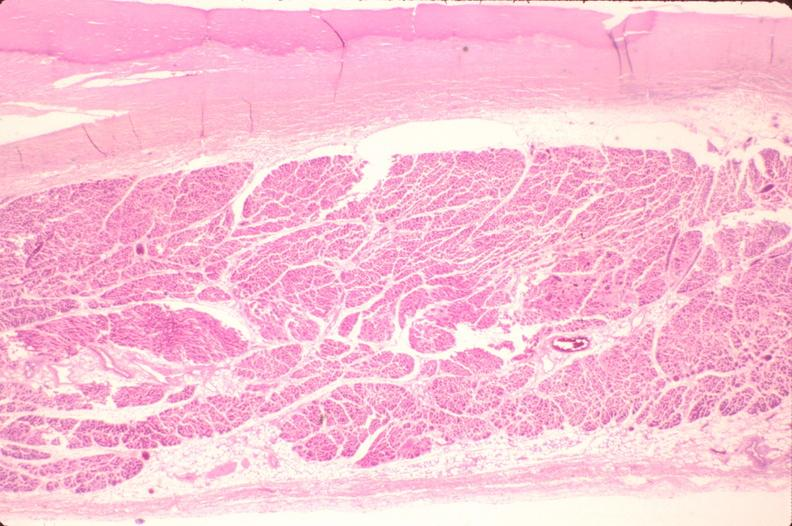does this image show heart, fibrosis, chronic rheumatic heart disease?
Answer the question using a single word or phrase. Yes 